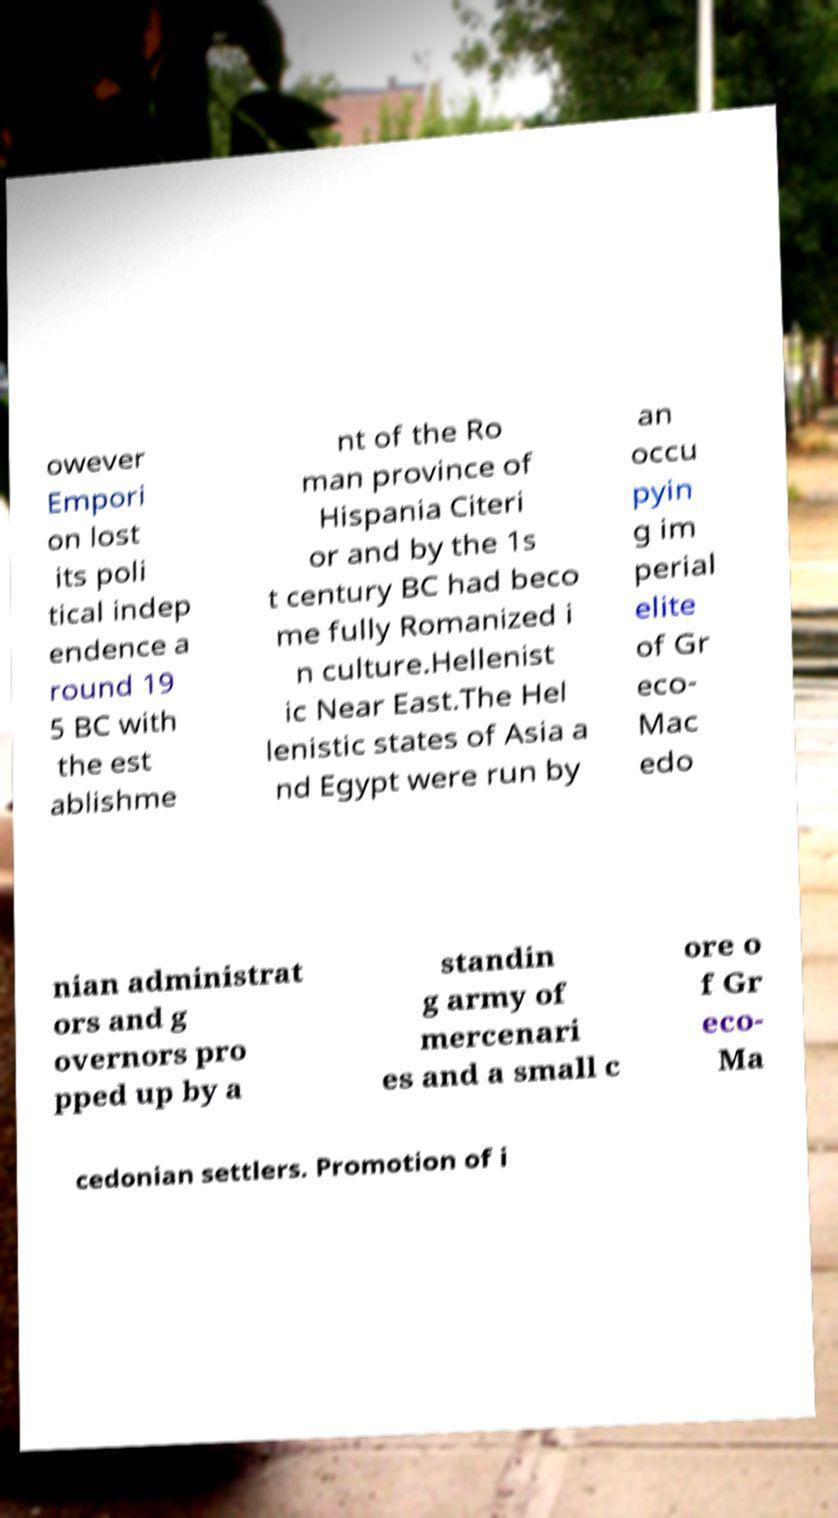Please read and relay the text visible in this image. What does it say? owever Empori on lost its poli tical indep endence a round 19 5 BC with the est ablishme nt of the Ro man province of Hispania Citeri or and by the 1s t century BC had beco me fully Romanized i n culture.Hellenist ic Near East.The Hel lenistic states of Asia a nd Egypt were run by an occu pyin g im perial elite of Gr eco- Mac edo nian administrat ors and g overnors pro pped up by a standin g army of mercenari es and a small c ore o f Gr eco- Ma cedonian settlers. Promotion of i 